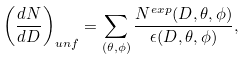Convert formula to latex. <formula><loc_0><loc_0><loc_500><loc_500>\left ( \frac { d N } { d D } \right ) _ { u n f } = \sum _ { ( \theta , \phi ) } \frac { N ^ { e x p } ( D , \theta , \phi ) } { \epsilon ( D , \theta , \phi ) } ,</formula> 